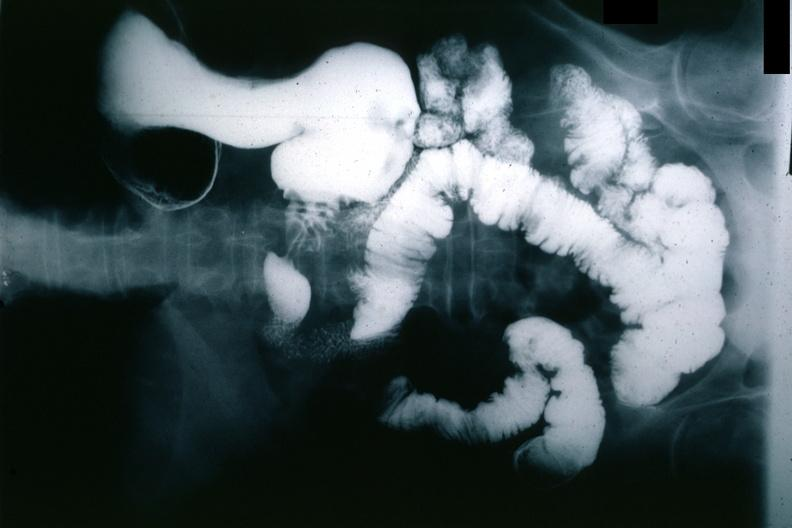what is present?
Answer the question using a single word or phrase. Gastrointestinal 